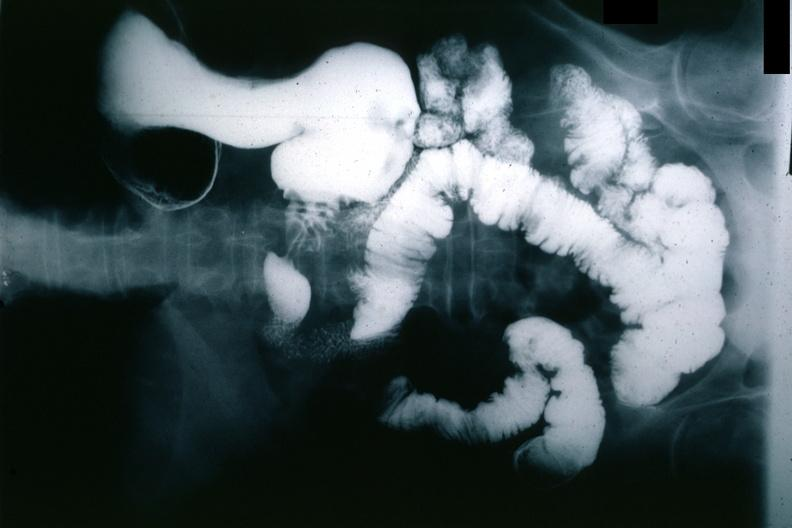what is present?
Answer the question using a single word or phrase. Gastrointestinal 